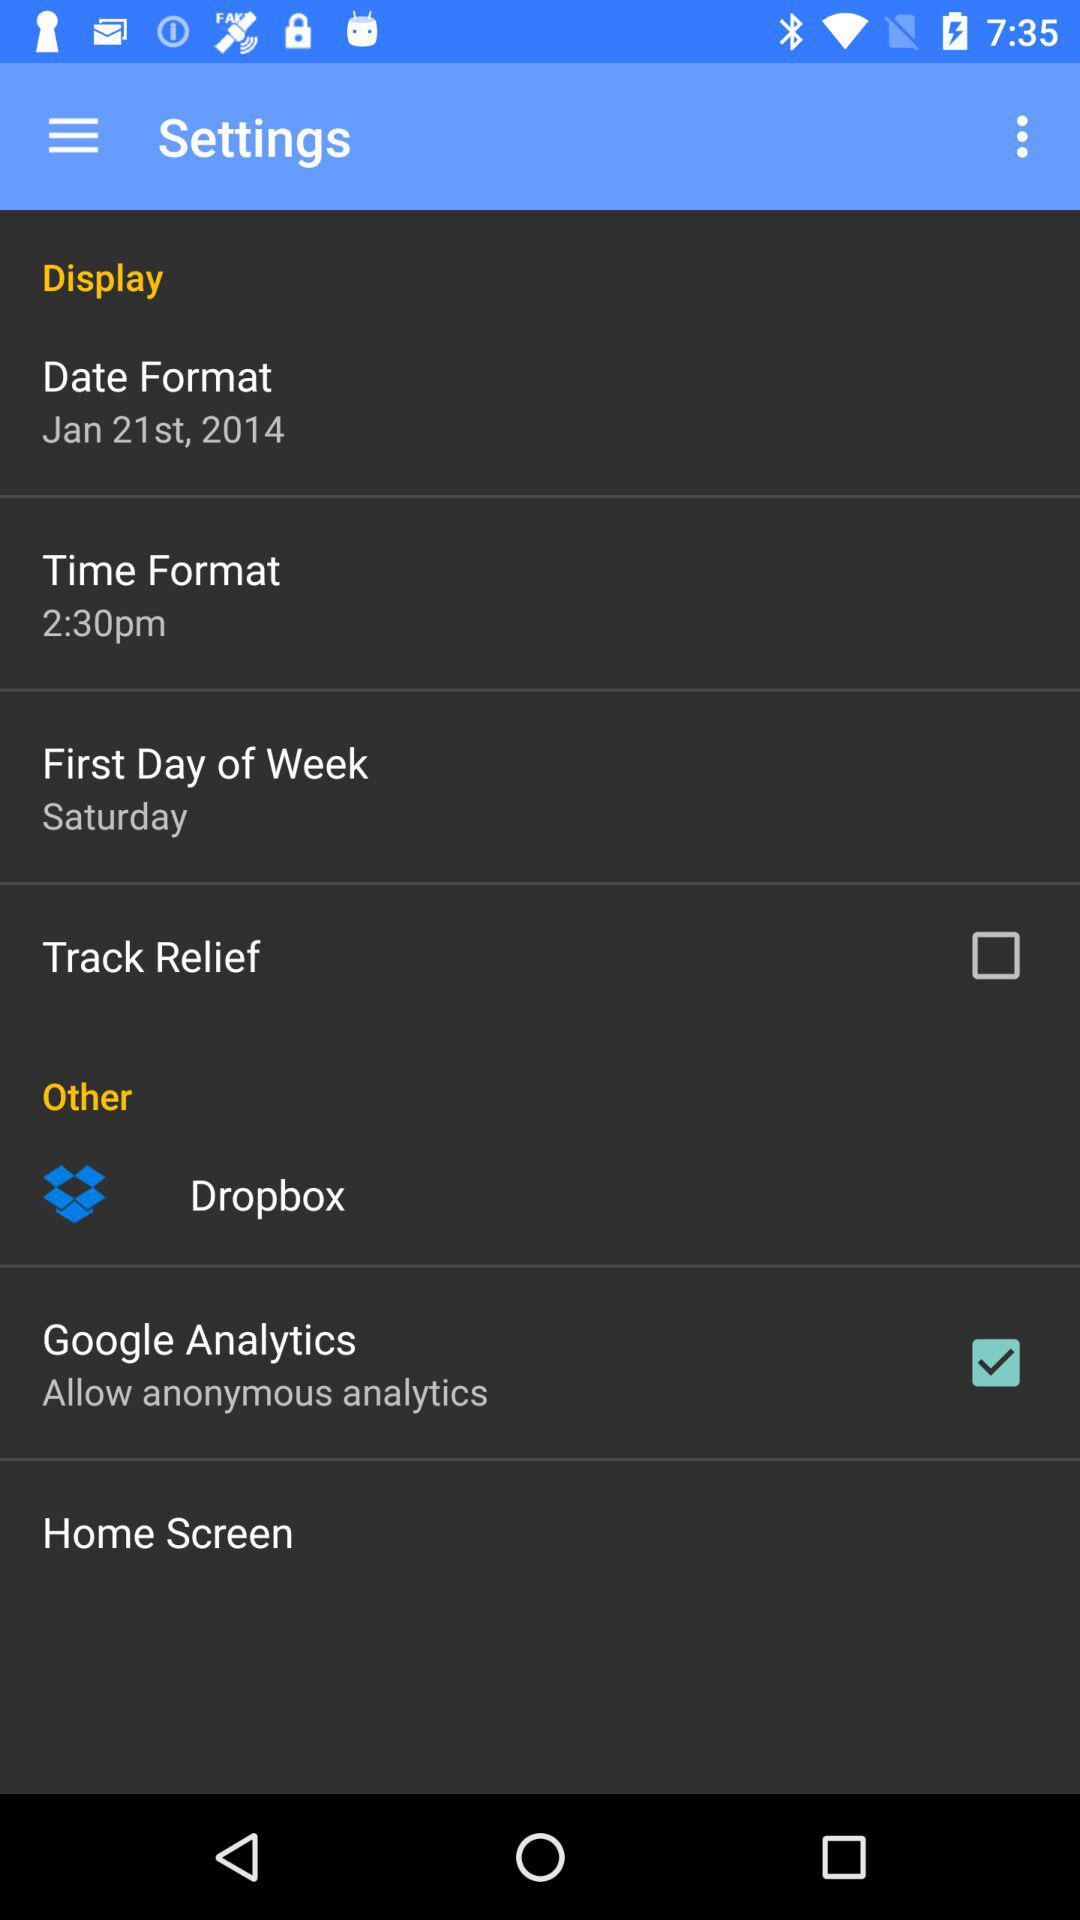What's the first day of the week? The first day of the week is Saturday. 